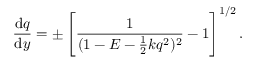Convert formula to latex. <formula><loc_0><loc_0><loc_500><loc_500>\frac { d q } { d y } = \pm \left [ \frac { 1 } { ( 1 - E - \frac { 1 } { 2 } k q ^ { 2 } ) ^ { 2 } } - 1 \right ] ^ { 1 / 2 } .</formula> 